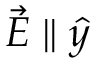<formula> <loc_0><loc_0><loc_500><loc_500>\vec { E } \| \hat { y }</formula> 